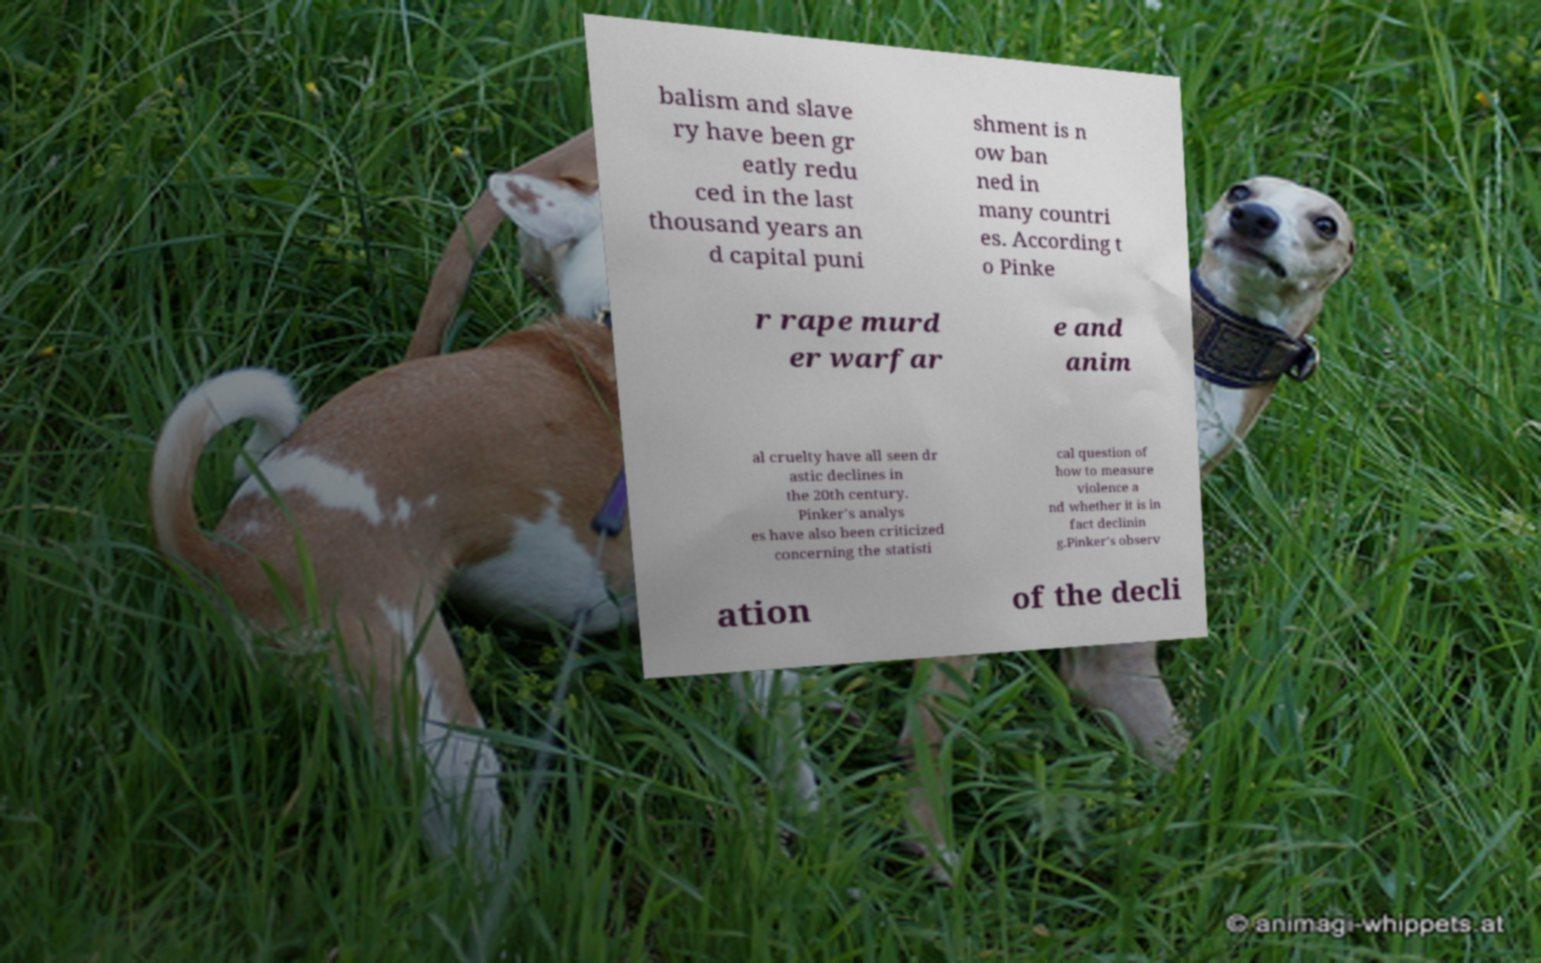I need the written content from this picture converted into text. Can you do that? balism and slave ry have been gr eatly redu ced in the last thousand years an d capital puni shment is n ow ban ned in many countri es. According t o Pinke r rape murd er warfar e and anim al cruelty have all seen dr astic declines in the 20th century. Pinker's analys es have also been criticized concerning the statisti cal question of how to measure violence a nd whether it is in fact declinin g.Pinker's observ ation of the decli 